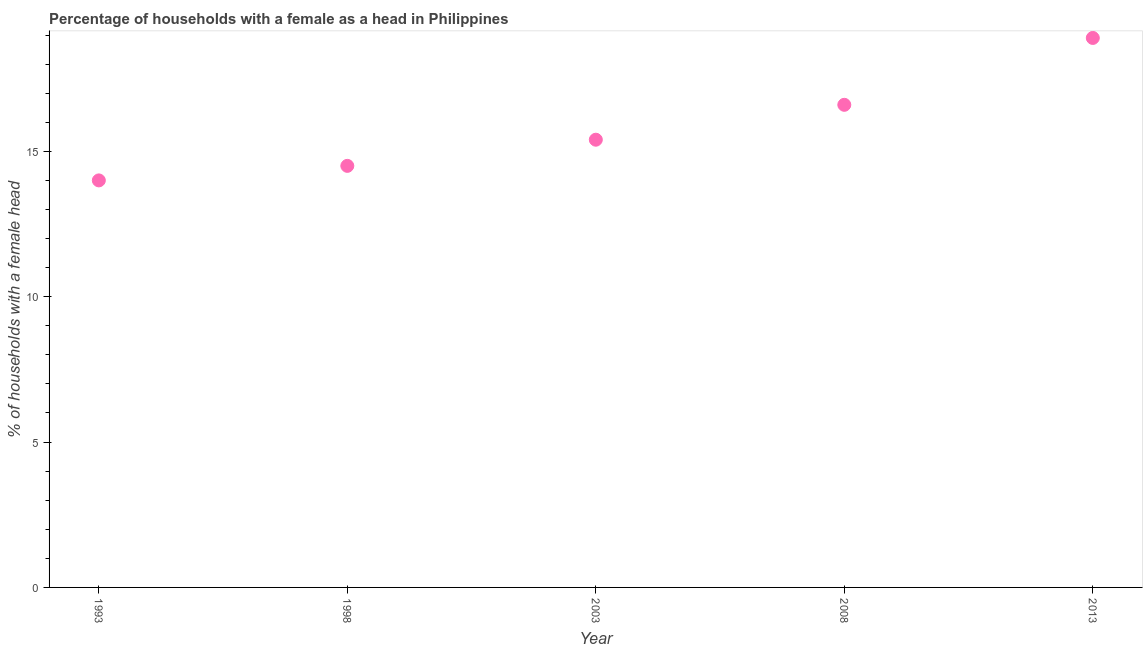What is the number of female supervised households in 2013?
Your answer should be compact. 18.9. In which year was the number of female supervised households minimum?
Keep it short and to the point. 1993. What is the sum of the number of female supervised households?
Offer a very short reply. 79.4. What is the difference between the number of female supervised households in 1998 and 2003?
Offer a very short reply. -0.9. What is the average number of female supervised households per year?
Your response must be concise. 15.88. What is the median number of female supervised households?
Offer a terse response. 15.4. What is the ratio of the number of female supervised households in 2003 to that in 2013?
Make the answer very short. 0.81. Is the number of female supervised households in 1998 less than that in 2008?
Offer a terse response. Yes. Is the difference between the number of female supervised households in 1993 and 2003 greater than the difference between any two years?
Give a very brief answer. No. What is the difference between the highest and the second highest number of female supervised households?
Keep it short and to the point. 2.3. Is the sum of the number of female supervised households in 1998 and 2003 greater than the maximum number of female supervised households across all years?
Your answer should be compact. Yes. What is the difference between the highest and the lowest number of female supervised households?
Provide a short and direct response. 4.9. Does the number of female supervised households monotonically increase over the years?
Give a very brief answer. Yes. How many years are there in the graph?
Provide a short and direct response. 5. What is the difference between two consecutive major ticks on the Y-axis?
Ensure brevity in your answer.  5. Are the values on the major ticks of Y-axis written in scientific E-notation?
Give a very brief answer. No. Does the graph contain any zero values?
Give a very brief answer. No. What is the title of the graph?
Provide a short and direct response. Percentage of households with a female as a head in Philippines. What is the label or title of the X-axis?
Provide a short and direct response. Year. What is the label or title of the Y-axis?
Provide a short and direct response. % of households with a female head. What is the % of households with a female head in 1993?
Make the answer very short. 14. What is the % of households with a female head in 2003?
Offer a terse response. 15.4. What is the difference between the % of households with a female head in 1993 and 2003?
Make the answer very short. -1.4. What is the difference between the % of households with a female head in 1993 and 2008?
Make the answer very short. -2.6. What is the difference between the % of households with a female head in 1998 and 2003?
Your answer should be compact. -0.9. What is the difference between the % of households with a female head in 1998 and 2008?
Ensure brevity in your answer.  -2.1. What is the difference between the % of households with a female head in 1998 and 2013?
Your answer should be very brief. -4.4. What is the difference between the % of households with a female head in 2003 and 2008?
Your answer should be compact. -1.2. What is the difference between the % of households with a female head in 2003 and 2013?
Your response must be concise. -3.5. What is the ratio of the % of households with a female head in 1993 to that in 1998?
Ensure brevity in your answer.  0.97. What is the ratio of the % of households with a female head in 1993 to that in 2003?
Give a very brief answer. 0.91. What is the ratio of the % of households with a female head in 1993 to that in 2008?
Your response must be concise. 0.84. What is the ratio of the % of households with a female head in 1993 to that in 2013?
Give a very brief answer. 0.74. What is the ratio of the % of households with a female head in 1998 to that in 2003?
Give a very brief answer. 0.94. What is the ratio of the % of households with a female head in 1998 to that in 2008?
Offer a terse response. 0.87. What is the ratio of the % of households with a female head in 1998 to that in 2013?
Keep it short and to the point. 0.77. What is the ratio of the % of households with a female head in 2003 to that in 2008?
Provide a succinct answer. 0.93. What is the ratio of the % of households with a female head in 2003 to that in 2013?
Give a very brief answer. 0.81. What is the ratio of the % of households with a female head in 2008 to that in 2013?
Your answer should be compact. 0.88. 